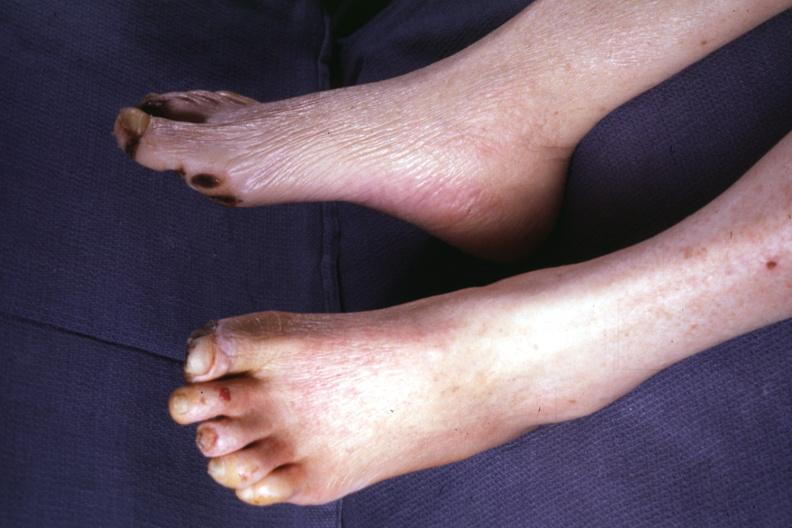s feet present?
Answer the question using a single word or phrase. Yes 